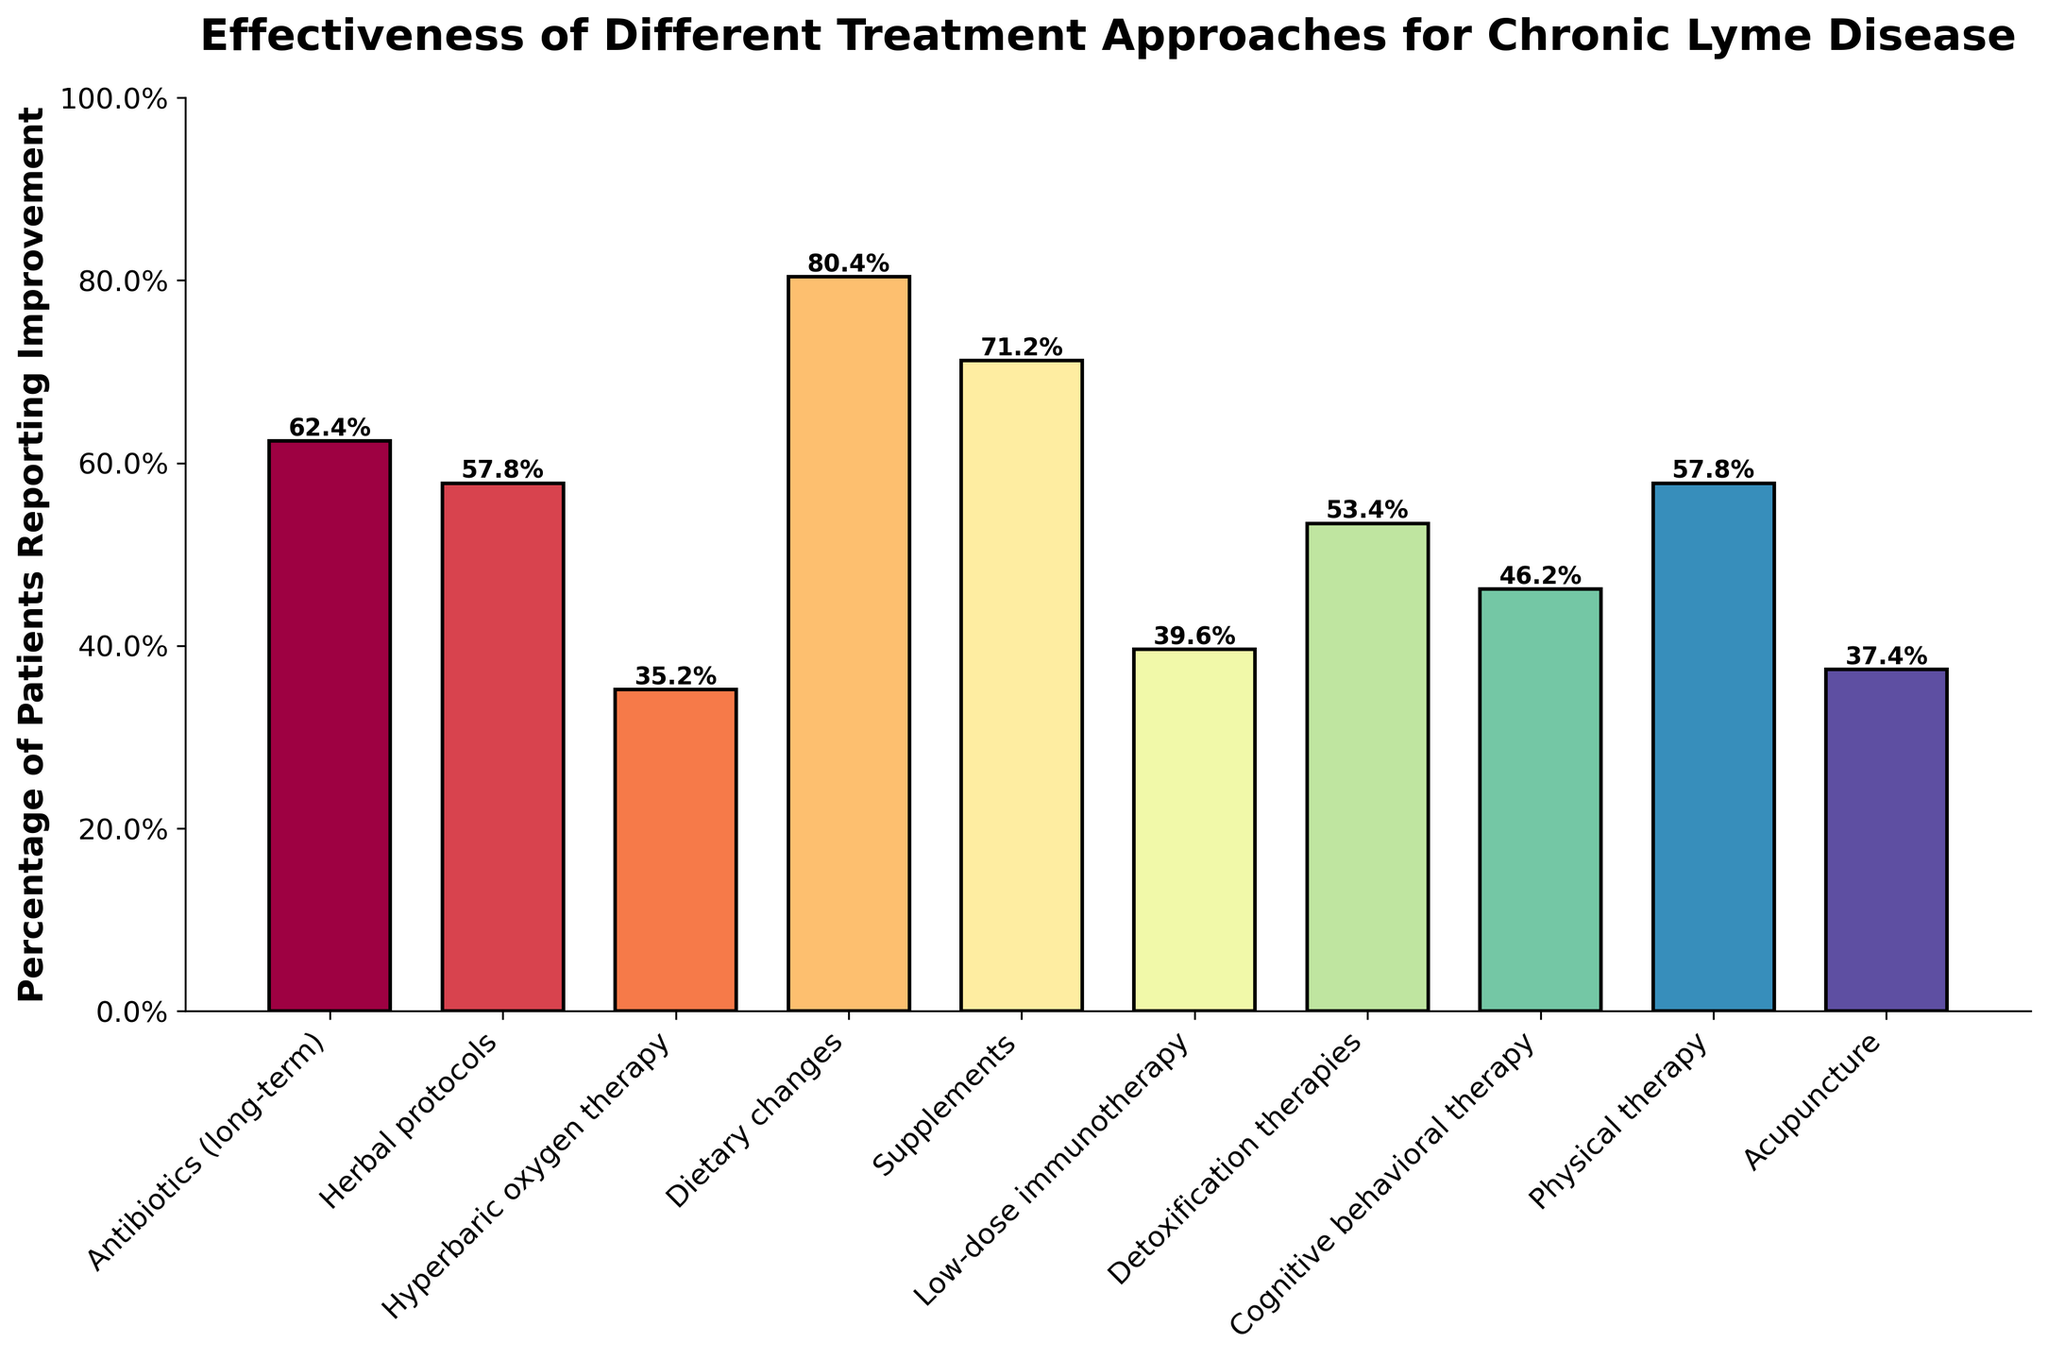What treatment approach has the highest percentage of patients reporting improvement? By looking at the heights of the bars, the tallest bar represents the treatment with the highest percentage. This is the bar for "Dietary changes."
Answer: Dietary changes Which treatment approach reports the lowest percentage of improvement? The shortest bar corresponds to the treatment approach with the lowest percentage of improvement, which is "Hyperbaric oxygen therapy."
Answer: Hyperbaric oxygen therapy How much higher is the percentage of patients reporting improvement with dietary changes compared to hyperbaric oxygen therapy? First, locate the percentages for dietary changes (80.4%) and hyperbaric oxygen therapy (35.2%). Then, subtract the smaller percentage from the larger: 80.4% - 35.2% = 45.2%.
Answer: 45.2% Are there any treatment approaches with the same percentage of patients reporting improvement? By visually comparing the heights of the bars, we can see that both "Herbal protocols" and "Physical therapy" have the same percentage, which is 57.8%.
Answer: Yes, Herbal protocols and Physical therapy What is the total percentage of patients that reported improvement for antibiotics (long-term), supplements, and detoxification therapies combined? Add the percentages for antibiotics (long-term) (62.4%), supplements (71.2%), and detoxification therapies (53.4%): 62.4% + 71.2% + 53.4% = 187%.
Answer: 187% Compare the percentages of patients reporting improvement between herbal protocols and low-dose immunotherapy. Which one is higher, and by how much? Herbal protocols have 57.8%, while low-dose immunotherapy has 39.6%. Subtract to find the difference: 57.8% - 39.6% = 18.2%. Thus, herbal protocols have a higher percentage by 18.2%.
Answer: Herbal protocols by 18.2% What is the average percentage of improvement reported for antibiotics (long-term), cognitive behavioral therapy, and acupuncture? Add the percentages for antibiotics (long-term) (62.4%), cognitive behavioral therapy (46.2%), and acupuncture (37.4%), then divide by 3: (62.4% + 46.2% + 37.4%) / 3 = 48.67%.
Answer: 48.67% Sort the treatment approaches in descending order based on the percentage of patients reporting improvement. By visually arranging the bars from tallest to shortest, the order is: Dietary changes (80.4%), Supplements (71.2%), Antibiotics (long-term) (62.4%), Herbal protocols (57.8%), Physical therapy (57.8%), Detoxification therapies (53.4%), Cognitive behavioral therapy (46.2%), Low-dose immunotherapy (39.6%), Acupuncture (37.4%), Hyperbaric oxygen therapy (35.2%).
Answer: Dietary changes, Supplements, Antibiotics (long-term), Herbal protocols, Physical therapy, Detoxification therapies, Cognitive behavioral therapy, Low-dose immunotherapy, Acupuncture, Hyperbaric oxygen therapy Which treatment approach shows an improvement percentage that is closer to 50%? By visually inspecting the bar heights, cognitive behavioral therapy at 46.2% is closer to 50% than any other treatment.
Answer: Cognitive behavioral therapy How much higher is the improvement percentage of supplements compared to antibiotics (long-term)? Locate the percentages for supplements (71.2%) and antibiotics (long-term) (62.4%), and subtract the smaller percentage from the larger: 71.2% - 62.4% = 8.8%.
Answer: 8.8% 